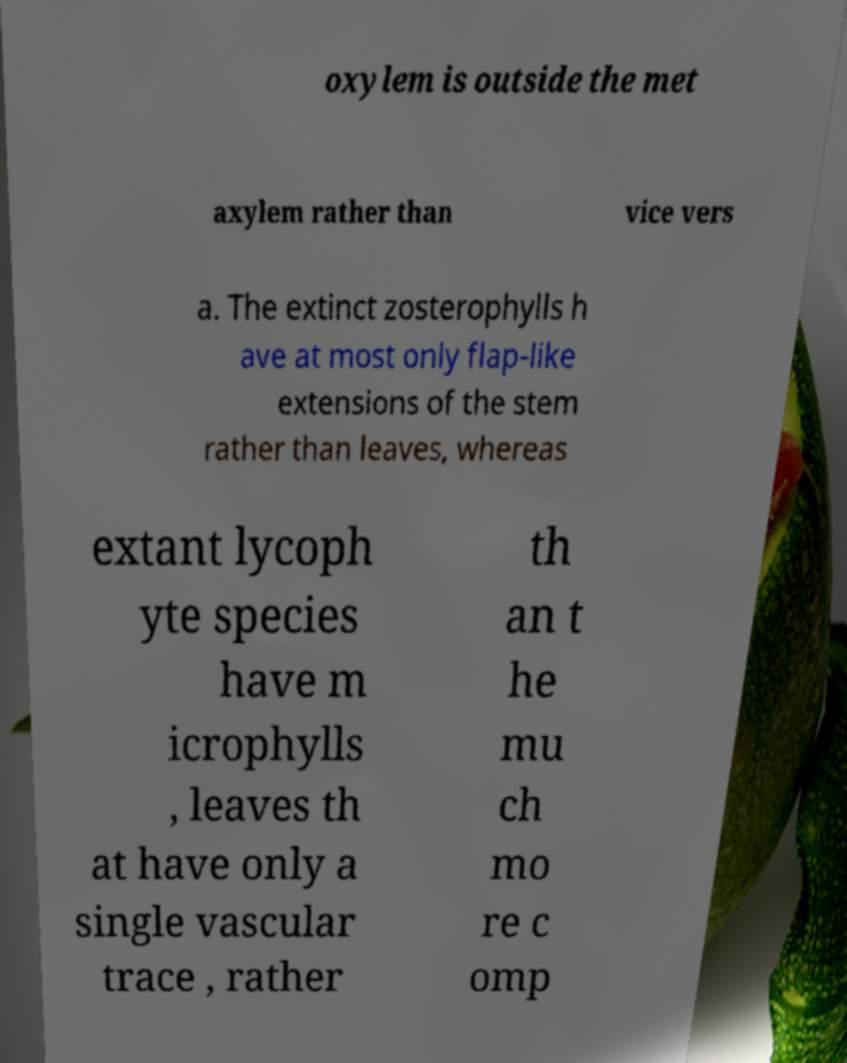Please identify and transcribe the text found in this image. oxylem is outside the met axylem rather than vice vers a. The extinct zosterophylls h ave at most only flap-like extensions of the stem rather than leaves, whereas extant lycoph yte species have m icrophylls , leaves th at have only a single vascular trace , rather th an t he mu ch mo re c omp 